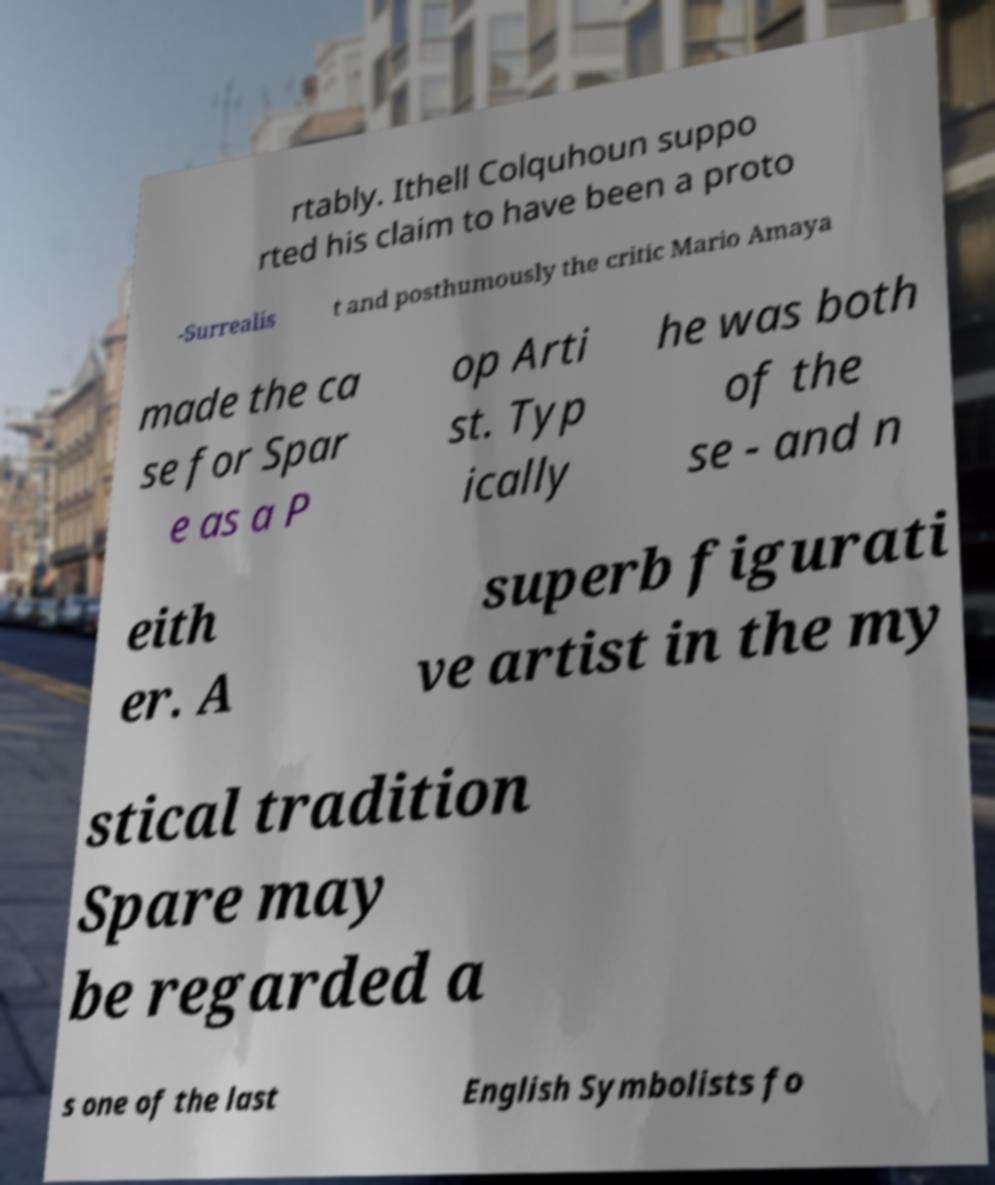I need the written content from this picture converted into text. Can you do that? rtably. Ithell Colquhoun suppo rted his claim to have been a proto -Surrealis t and posthumously the critic Mario Amaya made the ca se for Spar e as a P op Arti st. Typ ically he was both of the se - and n eith er. A superb figurati ve artist in the my stical tradition Spare may be regarded a s one of the last English Symbolists fo 